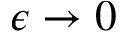Convert formula to latex. <formula><loc_0><loc_0><loc_500><loc_500>\epsilon \rightarrow 0</formula> 